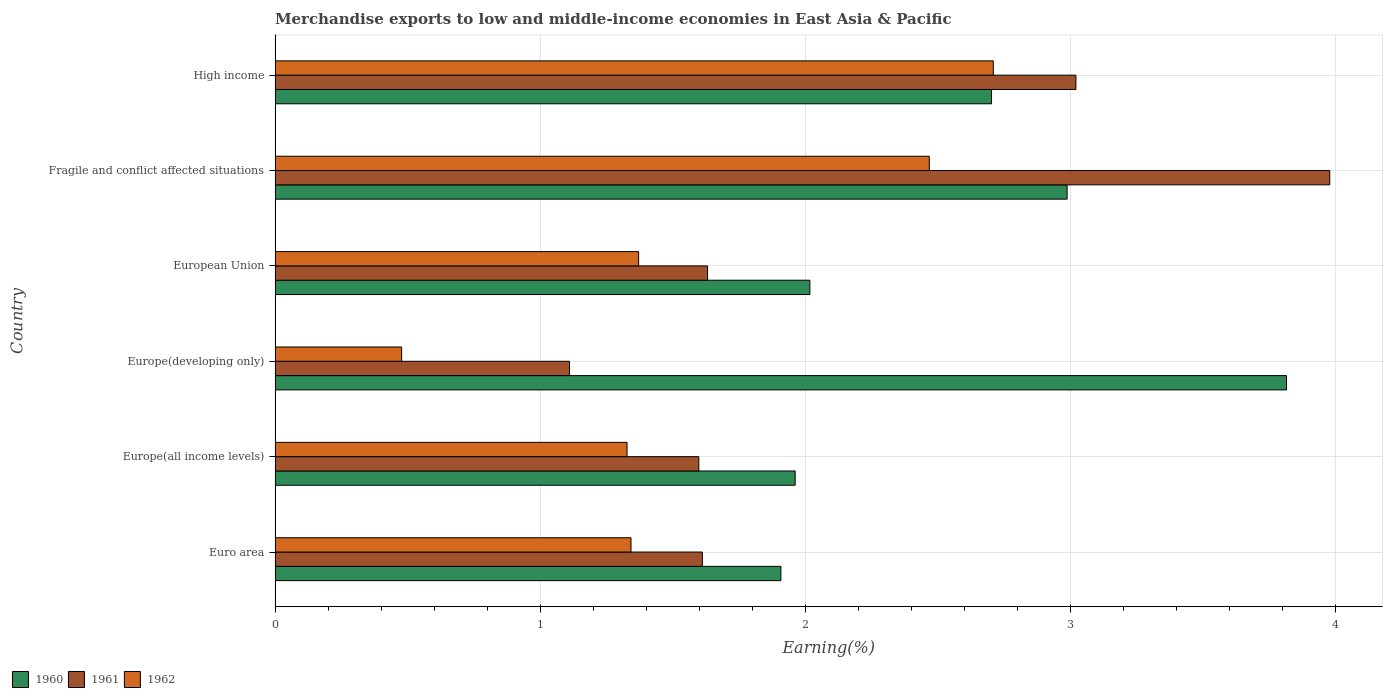How many different coloured bars are there?
Offer a very short reply. 3. How many groups of bars are there?
Keep it short and to the point. 6. Are the number of bars per tick equal to the number of legend labels?
Your answer should be compact. Yes. How many bars are there on the 2nd tick from the bottom?
Offer a terse response. 3. What is the label of the 5th group of bars from the top?
Your answer should be compact. Europe(all income levels). What is the percentage of amount earned from merchandise exports in 1961 in Euro area?
Give a very brief answer. 1.61. Across all countries, what is the maximum percentage of amount earned from merchandise exports in 1961?
Keep it short and to the point. 3.98. Across all countries, what is the minimum percentage of amount earned from merchandise exports in 1960?
Offer a terse response. 1.91. In which country was the percentage of amount earned from merchandise exports in 1961 maximum?
Provide a succinct answer. Fragile and conflict affected situations. What is the total percentage of amount earned from merchandise exports in 1960 in the graph?
Provide a succinct answer. 15.39. What is the difference between the percentage of amount earned from merchandise exports in 1962 in European Union and that in Fragile and conflict affected situations?
Offer a very short reply. -1.1. What is the difference between the percentage of amount earned from merchandise exports in 1961 in Europe(developing only) and the percentage of amount earned from merchandise exports in 1960 in European Union?
Your answer should be compact. -0.91. What is the average percentage of amount earned from merchandise exports in 1961 per country?
Keep it short and to the point. 2.16. What is the difference between the percentage of amount earned from merchandise exports in 1960 and percentage of amount earned from merchandise exports in 1961 in European Union?
Give a very brief answer. 0.39. In how many countries, is the percentage of amount earned from merchandise exports in 1960 greater than 0.6000000000000001 %?
Give a very brief answer. 6. What is the ratio of the percentage of amount earned from merchandise exports in 1960 in Euro area to that in High income?
Your response must be concise. 0.71. What is the difference between the highest and the second highest percentage of amount earned from merchandise exports in 1961?
Make the answer very short. 0.96. What is the difference between the highest and the lowest percentage of amount earned from merchandise exports in 1961?
Provide a short and direct response. 2.87. In how many countries, is the percentage of amount earned from merchandise exports in 1960 greater than the average percentage of amount earned from merchandise exports in 1960 taken over all countries?
Your answer should be compact. 3. Is the sum of the percentage of amount earned from merchandise exports in 1960 in Euro area and Europe(all income levels) greater than the maximum percentage of amount earned from merchandise exports in 1961 across all countries?
Give a very brief answer. No. Are all the bars in the graph horizontal?
Offer a very short reply. Yes. How many countries are there in the graph?
Your answer should be compact. 6. What is the difference between two consecutive major ticks on the X-axis?
Make the answer very short. 1. Does the graph contain grids?
Ensure brevity in your answer.  Yes. Where does the legend appear in the graph?
Offer a terse response. Bottom left. How are the legend labels stacked?
Give a very brief answer. Horizontal. What is the title of the graph?
Provide a succinct answer. Merchandise exports to low and middle-income economies in East Asia & Pacific. What is the label or title of the X-axis?
Provide a succinct answer. Earning(%). What is the Earning(%) of 1960 in Euro area?
Keep it short and to the point. 1.91. What is the Earning(%) of 1961 in Euro area?
Ensure brevity in your answer.  1.61. What is the Earning(%) of 1962 in Euro area?
Your response must be concise. 1.34. What is the Earning(%) in 1960 in Europe(all income levels)?
Ensure brevity in your answer.  1.96. What is the Earning(%) of 1961 in Europe(all income levels)?
Offer a terse response. 1.6. What is the Earning(%) of 1962 in Europe(all income levels)?
Provide a succinct answer. 1.33. What is the Earning(%) in 1960 in Europe(developing only)?
Your answer should be compact. 3.82. What is the Earning(%) in 1961 in Europe(developing only)?
Your answer should be compact. 1.11. What is the Earning(%) in 1962 in Europe(developing only)?
Make the answer very short. 0.48. What is the Earning(%) in 1960 in European Union?
Offer a very short reply. 2.02. What is the Earning(%) in 1961 in European Union?
Offer a terse response. 1.63. What is the Earning(%) in 1962 in European Union?
Your response must be concise. 1.37. What is the Earning(%) of 1960 in Fragile and conflict affected situations?
Make the answer very short. 2.99. What is the Earning(%) in 1961 in Fragile and conflict affected situations?
Ensure brevity in your answer.  3.98. What is the Earning(%) of 1962 in Fragile and conflict affected situations?
Keep it short and to the point. 2.47. What is the Earning(%) in 1960 in High income?
Make the answer very short. 2.7. What is the Earning(%) of 1961 in High income?
Your response must be concise. 3.02. What is the Earning(%) of 1962 in High income?
Offer a very short reply. 2.71. Across all countries, what is the maximum Earning(%) of 1960?
Your answer should be very brief. 3.82. Across all countries, what is the maximum Earning(%) in 1961?
Provide a short and direct response. 3.98. Across all countries, what is the maximum Earning(%) in 1962?
Give a very brief answer. 2.71. Across all countries, what is the minimum Earning(%) of 1960?
Offer a terse response. 1.91. Across all countries, what is the minimum Earning(%) of 1961?
Give a very brief answer. 1.11. Across all countries, what is the minimum Earning(%) of 1962?
Your answer should be very brief. 0.48. What is the total Earning(%) in 1960 in the graph?
Keep it short and to the point. 15.39. What is the total Earning(%) in 1961 in the graph?
Give a very brief answer. 12.95. What is the total Earning(%) of 1962 in the graph?
Your answer should be very brief. 9.7. What is the difference between the Earning(%) in 1960 in Euro area and that in Europe(all income levels)?
Make the answer very short. -0.05. What is the difference between the Earning(%) of 1961 in Euro area and that in Europe(all income levels)?
Your answer should be very brief. 0.01. What is the difference between the Earning(%) of 1962 in Euro area and that in Europe(all income levels)?
Make the answer very short. 0.01. What is the difference between the Earning(%) in 1960 in Euro area and that in Europe(developing only)?
Make the answer very short. -1.91. What is the difference between the Earning(%) in 1961 in Euro area and that in Europe(developing only)?
Your response must be concise. 0.5. What is the difference between the Earning(%) of 1962 in Euro area and that in Europe(developing only)?
Provide a succinct answer. 0.87. What is the difference between the Earning(%) in 1960 in Euro area and that in European Union?
Provide a short and direct response. -0.11. What is the difference between the Earning(%) of 1961 in Euro area and that in European Union?
Offer a very short reply. -0.02. What is the difference between the Earning(%) of 1962 in Euro area and that in European Union?
Provide a short and direct response. -0.03. What is the difference between the Earning(%) of 1960 in Euro area and that in Fragile and conflict affected situations?
Your response must be concise. -1.08. What is the difference between the Earning(%) in 1961 in Euro area and that in Fragile and conflict affected situations?
Make the answer very short. -2.37. What is the difference between the Earning(%) in 1962 in Euro area and that in Fragile and conflict affected situations?
Keep it short and to the point. -1.13. What is the difference between the Earning(%) of 1960 in Euro area and that in High income?
Provide a short and direct response. -0.79. What is the difference between the Earning(%) in 1961 in Euro area and that in High income?
Your answer should be very brief. -1.41. What is the difference between the Earning(%) in 1962 in Euro area and that in High income?
Offer a terse response. -1.37. What is the difference between the Earning(%) in 1960 in Europe(all income levels) and that in Europe(developing only)?
Your response must be concise. -1.85. What is the difference between the Earning(%) in 1961 in Europe(all income levels) and that in Europe(developing only)?
Give a very brief answer. 0.49. What is the difference between the Earning(%) of 1962 in Europe(all income levels) and that in Europe(developing only)?
Provide a succinct answer. 0.85. What is the difference between the Earning(%) of 1960 in Europe(all income levels) and that in European Union?
Offer a very short reply. -0.06. What is the difference between the Earning(%) of 1961 in Europe(all income levels) and that in European Union?
Make the answer very short. -0.03. What is the difference between the Earning(%) of 1962 in Europe(all income levels) and that in European Union?
Your answer should be compact. -0.04. What is the difference between the Earning(%) of 1960 in Europe(all income levels) and that in Fragile and conflict affected situations?
Make the answer very short. -1.03. What is the difference between the Earning(%) of 1961 in Europe(all income levels) and that in Fragile and conflict affected situations?
Ensure brevity in your answer.  -2.38. What is the difference between the Earning(%) in 1962 in Europe(all income levels) and that in Fragile and conflict affected situations?
Your answer should be compact. -1.14. What is the difference between the Earning(%) in 1960 in Europe(all income levels) and that in High income?
Give a very brief answer. -0.74. What is the difference between the Earning(%) in 1961 in Europe(all income levels) and that in High income?
Keep it short and to the point. -1.42. What is the difference between the Earning(%) in 1962 in Europe(all income levels) and that in High income?
Offer a terse response. -1.38. What is the difference between the Earning(%) of 1960 in Europe(developing only) and that in European Union?
Keep it short and to the point. 1.8. What is the difference between the Earning(%) in 1961 in Europe(developing only) and that in European Union?
Keep it short and to the point. -0.52. What is the difference between the Earning(%) of 1962 in Europe(developing only) and that in European Union?
Give a very brief answer. -0.89. What is the difference between the Earning(%) of 1960 in Europe(developing only) and that in Fragile and conflict affected situations?
Give a very brief answer. 0.83. What is the difference between the Earning(%) in 1961 in Europe(developing only) and that in Fragile and conflict affected situations?
Your answer should be very brief. -2.87. What is the difference between the Earning(%) in 1962 in Europe(developing only) and that in Fragile and conflict affected situations?
Keep it short and to the point. -1.99. What is the difference between the Earning(%) in 1960 in Europe(developing only) and that in High income?
Provide a short and direct response. 1.11. What is the difference between the Earning(%) in 1961 in Europe(developing only) and that in High income?
Give a very brief answer. -1.91. What is the difference between the Earning(%) of 1962 in Europe(developing only) and that in High income?
Provide a short and direct response. -2.23. What is the difference between the Earning(%) of 1960 in European Union and that in Fragile and conflict affected situations?
Ensure brevity in your answer.  -0.97. What is the difference between the Earning(%) of 1961 in European Union and that in Fragile and conflict affected situations?
Your response must be concise. -2.35. What is the difference between the Earning(%) of 1962 in European Union and that in Fragile and conflict affected situations?
Provide a succinct answer. -1.1. What is the difference between the Earning(%) of 1960 in European Union and that in High income?
Ensure brevity in your answer.  -0.69. What is the difference between the Earning(%) of 1961 in European Union and that in High income?
Make the answer very short. -1.39. What is the difference between the Earning(%) of 1962 in European Union and that in High income?
Make the answer very short. -1.34. What is the difference between the Earning(%) of 1960 in Fragile and conflict affected situations and that in High income?
Offer a very short reply. 0.29. What is the difference between the Earning(%) of 1961 in Fragile and conflict affected situations and that in High income?
Your response must be concise. 0.96. What is the difference between the Earning(%) of 1962 in Fragile and conflict affected situations and that in High income?
Offer a very short reply. -0.24. What is the difference between the Earning(%) in 1960 in Euro area and the Earning(%) in 1961 in Europe(all income levels)?
Your answer should be compact. 0.31. What is the difference between the Earning(%) in 1960 in Euro area and the Earning(%) in 1962 in Europe(all income levels)?
Offer a terse response. 0.58. What is the difference between the Earning(%) of 1961 in Euro area and the Earning(%) of 1962 in Europe(all income levels)?
Keep it short and to the point. 0.28. What is the difference between the Earning(%) of 1960 in Euro area and the Earning(%) of 1961 in Europe(developing only)?
Provide a succinct answer. 0.8. What is the difference between the Earning(%) of 1960 in Euro area and the Earning(%) of 1962 in Europe(developing only)?
Provide a succinct answer. 1.43. What is the difference between the Earning(%) in 1961 in Euro area and the Earning(%) in 1962 in Europe(developing only)?
Your answer should be very brief. 1.13. What is the difference between the Earning(%) in 1960 in Euro area and the Earning(%) in 1961 in European Union?
Your answer should be compact. 0.28. What is the difference between the Earning(%) in 1960 in Euro area and the Earning(%) in 1962 in European Union?
Keep it short and to the point. 0.54. What is the difference between the Earning(%) of 1961 in Euro area and the Earning(%) of 1962 in European Union?
Your answer should be very brief. 0.24. What is the difference between the Earning(%) in 1960 in Euro area and the Earning(%) in 1961 in Fragile and conflict affected situations?
Provide a succinct answer. -2.07. What is the difference between the Earning(%) of 1960 in Euro area and the Earning(%) of 1962 in Fragile and conflict affected situations?
Your answer should be very brief. -0.56. What is the difference between the Earning(%) of 1961 in Euro area and the Earning(%) of 1962 in Fragile and conflict affected situations?
Provide a short and direct response. -0.86. What is the difference between the Earning(%) in 1960 in Euro area and the Earning(%) in 1961 in High income?
Offer a very short reply. -1.11. What is the difference between the Earning(%) of 1960 in Euro area and the Earning(%) of 1962 in High income?
Ensure brevity in your answer.  -0.8. What is the difference between the Earning(%) in 1961 in Euro area and the Earning(%) in 1962 in High income?
Ensure brevity in your answer.  -1.1. What is the difference between the Earning(%) in 1960 in Europe(all income levels) and the Earning(%) in 1961 in Europe(developing only)?
Your answer should be very brief. 0.85. What is the difference between the Earning(%) in 1960 in Europe(all income levels) and the Earning(%) in 1962 in Europe(developing only)?
Provide a short and direct response. 1.48. What is the difference between the Earning(%) of 1961 in Europe(all income levels) and the Earning(%) of 1962 in Europe(developing only)?
Keep it short and to the point. 1.12. What is the difference between the Earning(%) in 1960 in Europe(all income levels) and the Earning(%) in 1961 in European Union?
Your answer should be very brief. 0.33. What is the difference between the Earning(%) of 1960 in Europe(all income levels) and the Earning(%) of 1962 in European Union?
Give a very brief answer. 0.59. What is the difference between the Earning(%) of 1961 in Europe(all income levels) and the Earning(%) of 1962 in European Union?
Make the answer very short. 0.23. What is the difference between the Earning(%) of 1960 in Europe(all income levels) and the Earning(%) of 1961 in Fragile and conflict affected situations?
Ensure brevity in your answer.  -2.02. What is the difference between the Earning(%) of 1960 in Europe(all income levels) and the Earning(%) of 1962 in Fragile and conflict affected situations?
Provide a succinct answer. -0.51. What is the difference between the Earning(%) in 1961 in Europe(all income levels) and the Earning(%) in 1962 in Fragile and conflict affected situations?
Keep it short and to the point. -0.87. What is the difference between the Earning(%) of 1960 in Europe(all income levels) and the Earning(%) of 1961 in High income?
Ensure brevity in your answer.  -1.06. What is the difference between the Earning(%) in 1960 in Europe(all income levels) and the Earning(%) in 1962 in High income?
Your response must be concise. -0.75. What is the difference between the Earning(%) of 1961 in Europe(all income levels) and the Earning(%) of 1962 in High income?
Make the answer very short. -1.11. What is the difference between the Earning(%) in 1960 in Europe(developing only) and the Earning(%) in 1961 in European Union?
Your answer should be very brief. 2.18. What is the difference between the Earning(%) of 1960 in Europe(developing only) and the Earning(%) of 1962 in European Union?
Give a very brief answer. 2.44. What is the difference between the Earning(%) of 1961 in Europe(developing only) and the Earning(%) of 1962 in European Union?
Provide a succinct answer. -0.26. What is the difference between the Earning(%) of 1960 in Europe(developing only) and the Earning(%) of 1961 in Fragile and conflict affected situations?
Make the answer very short. -0.16. What is the difference between the Earning(%) in 1960 in Europe(developing only) and the Earning(%) in 1962 in Fragile and conflict affected situations?
Provide a short and direct response. 1.35. What is the difference between the Earning(%) of 1961 in Europe(developing only) and the Earning(%) of 1962 in Fragile and conflict affected situations?
Your answer should be compact. -1.36. What is the difference between the Earning(%) in 1960 in Europe(developing only) and the Earning(%) in 1961 in High income?
Provide a short and direct response. 0.79. What is the difference between the Earning(%) in 1960 in Europe(developing only) and the Earning(%) in 1962 in High income?
Offer a terse response. 1.11. What is the difference between the Earning(%) of 1961 in Europe(developing only) and the Earning(%) of 1962 in High income?
Your answer should be compact. -1.6. What is the difference between the Earning(%) in 1960 in European Union and the Earning(%) in 1961 in Fragile and conflict affected situations?
Provide a short and direct response. -1.96. What is the difference between the Earning(%) of 1960 in European Union and the Earning(%) of 1962 in Fragile and conflict affected situations?
Your answer should be compact. -0.45. What is the difference between the Earning(%) of 1961 in European Union and the Earning(%) of 1962 in Fragile and conflict affected situations?
Provide a short and direct response. -0.84. What is the difference between the Earning(%) of 1960 in European Union and the Earning(%) of 1961 in High income?
Give a very brief answer. -1. What is the difference between the Earning(%) in 1960 in European Union and the Earning(%) in 1962 in High income?
Your answer should be very brief. -0.69. What is the difference between the Earning(%) in 1961 in European Union and the Earning(%) in 1962 in High income?
Offer a very short reply. -1.08. What is the difference between the Earning(%) of 1960 in Fragile and conflict affected situations and the Earning(%) of 1961 in High income?
Keep it short and to the point. -0.03. What is the difference between the Earning(%) in 1960 in Fragile and conflict affected situations and the Earning(%) in 1962 in High income?
Your answer should be very brief. 0.28. What is the difference between the Earning(%) in 1961 in Fragile and conflict affected situations and the Earning(%) in 1962 in High income?
Provide a succinct answer. 1.27. What is the average Earning(%) in 1960 per country?
Ensure brevity in your answer.  2.57. What is the average Earning(%) in 1961 per country?
Give a very brief answer. 2.16. What is the average Earning(%) of 1962 per country?
Your answer should be compact. 1.62. What is the difference between the Earning(%) in 1960 and Earning(%) in 1961 in Euro area?
Keep it short and to the point. 0.3. What is the difference between the Earning(%) of 1960 and Earning(%) of 1962 in Euro area?
Give a very brief answer. 0.57. What is the difference between the Earning(%) of 1961 and Earning(%) of 1962 in Euro area?
Keep it short and to the point. 0.27. What is the difference between the Earning(%) of 1960 and Earning(%) of 1961 in Europe(all income levels)?
Provide a short and direct response. 0.36. What is the difference between the Earning(%) of 1960 and Earning(%) of 1962 in Europe(all income levels)?
Provide a short and direct response. 0.63. What is the difference between the Earning(%) of 1961 and Earning(%) of 1962 in Europe(all income levels)?
Offer a terse response. 0.27. What is the difference between the Earning(%) in 1960 and Earning(%) in 1961 in Europe(developing only)?
Your answer should be compact. 2.7. What is the difference between the Earning(%) in 1960 and Earning(%) in 1962 in Europe(developing only)?
Offer a very short reply. 3.34. What is the difference between the Earning(%) in 1961 and Earning(%) in 1962 in Europe(developing only)?
Your answer should be very brief. 0.63. What is the difference between the Earning(%) of 1960 and Earning(%) of 1961 in European Union?
Keep it short and to the point. 0.39. What is the difference between the Earning(%) of 1960 and Earning(%) of 1962 in European Union?
Your answer should be compact. 0.65. What is the difference between the Earning(%) in 1961 and Earning(%) in 1962 in European Union?
Your answer should be very brief. 0.26. What is the difference between the Earning(%) in 1960 and Earning(%) in 1961 in Fragile and conflict affected situations?
Keep it short and to the point. -0.99. What is the difference between the Earning(%) in 1960 and Earning(%) in 1962 in Fragile and conflict affected situations?
Your answer should be very brief. 0.52. What is the difference between the Earning(%) of 1961 and Earning(%) of 1962 in Fragile and conflict affected situations?
Offer a terse response. 1.51. What is the difference between the Earning(%) of 1960 and Earning(%) of 1961 in High income?
Give a very brief answer. -0.32. What is the difference between the Earning(%) in 1960 and Earning(%) in 1962 in High income?
Your answer should be very brief. -0.01. What is the difference between the Earning(%) of 1961 and Earning(%) of 1962 in High income?
Give a very brief answer. 0.31. What is the ratio of the Earning(%) of 1960 in Euro area to that in Europe(all income levels)?
Your response must be concise. 0.97. What is the ratio of the Earning(%) of 1961 in Euro area to that in Europe(all income levels)?
Your answer should be compact. 1.01. What is the ratio of the Earning(%) in 1962 in Euro area to that in Europe(all income levels)?
Provide a succinct answer. 1.01. What is the ratio of the Earning(%) of 1960 in Euro area to that in Europe(developing only)?
Keep it short and to the point. 0.5. What is the ratio of the Earning(%) in 1961 in Euro area to that in Europe(developing only)?
Keep it short and to the point. 1.45. What is the ratio of the Earning(%) in 1962 in Euro area to that in Europe(developing only)?
Offer a very short reply. 2.81. What is the ratio of the Earning(%) in 1960 in Euro area to that in European Union?
Your answer should be compact. 0.95. What is the ratio of the Earning(%) of 1961 in Euro area to that in European Union?
Your response must be concise. 0.99. What is the ratio of the Earning(%) of 1962 in Euro area to that in European Union?
Your answer should be very brief. 0.98. What is the ratio of the Earning(%) in 1960 in Euro area to that in Fragile and conflict affected situations?
Offer a terse response. 0.64. What is the ratio of the Earning(%) of 1961 in Euro area to that in Fragile and conflict affected situations?
Offer a terse response. 0.41. What is the ratio of the Earning(%) of 1962 in Euro area to that in Fragile and conflict affected situations?
Offer a very short reply. 0.54. What is the ratio of the Earning(%) in 1960 in Euro area to that in High income?
Provide a succinct answer. 0.71. What is the ratio of the Earning(%) in 1961 in Euro area to that in High income?
Provide a succinct answer. 0.53. What is the ratio of the Earning(%) in 1962 in Euro area to that in High income?
Provide a short and direct response. 0.5. What is the ratio of the Earning(%) of 1960 in Europe(all income levels) to that in Europe(developing only)?
Your response must be concise. 0.51. What is the ratio of the Earning(%) in 1961 in Europe(all income levels) to that in Europe(developing only)?
Ensure brevity in your answer.  1.44. What is the ratio of the Earning(%) in 1962 in Europe(all income levels) to that in Europe(developing only)?
Offer a terse response. 2.78. What is the ratio of the Earning(%) in 1960 in Europe(all income levels) to that in European Union?
Keep it short and to the point. 0.97. What is the ratio of the Earning(%) of 1961 in Europe(all income levels) to that in European Union?
Ensure brevity in your answer.  0.98. What is the ratio of the Earning(%) in 1962 in Europe(all income levels) to that in European Union?
Provide a succinct answer. 0.97. What is the ratio of the Earning(%) in 1960 in Europe(all income levels) to that in Fragile and conflict affected situations?
Your answer should be compact. 0.66. What is the ratio of the Earning(%) of 1961 in Europe(all income levels) to that in Fragile and conflict affected situations?
Keep it short and to the point. 0.4. What is the ratio of the Earning(%) of 1962 in Europe(all income levels) to that in Fragile and conflict affected situations?
Give a very brief answer. 0.54. What is the ratio of the Earning(%) of 1960 in Europe(all income levels) to that in High income?
Ensure brevity in your answer.  0.73. What is the ratio of the Earning(%) in 1961 in Europe(all income levels) to that in High income?
Make the answer very short. 0.53. What is the ratio of the Earning(%) of 1962 in Europe(all income levels) to that in High income?
Your answer should be very brief. 0.49. What is the ratio of the Earning(%) of 1960 in Europe(developing only) to that in European Union?
Offer a terse response. 1.89. What is the ratio of the Earning(%) of 1961 in Europe(developing only) to that in European Union?
Offer a terse response. 0.68. What is the ratio of the Earning(%) of 1962 in Europe(developing only) to that in European Union?
Offer a very short reply. 0.35. What is the ratio of the Earning(%) of 1960 in Europe(developing only) to that in Fragile and conflict affected situations?
Provide a short and direct response. 1.28. What is the ratio of the Earning(%) in 1961 in Europe(developing only) to that in Fragile and conflict affected situations?
Keep it short and to the point. 0.28. What is the ratio of the Earning(%) of 1962 in Europe(developing only) to that in Fragile and conflict affected situations?
Offer a terse response. 0.19. What is the ratio of the Earning(%) in 1960 in Europe(developing only) to that in High income?
Offer a very short reply. 1.41. What is the ratio of the Earning(%) of 1961 in Europe(developing only) to that in High income?
Your answer should be very brief. 0.37. What is the ratio of the Earning(%) of 1962 in Europe(developing only) to that in High income?
Your answer should be compact. 0.18. What is the ratio of the Earning(%) in 1960 in European Union to that in Fragile and conflict affected situations?
Ensure brevity in your answer.  0.68. What is the ratio of the Earning(%) in 1961 in European Union to that in Fragile and conflict affected situations?
Offer a terse response. 0.41. What is the ratio of the Earning(%) in 1962 in European Union to that in Fragile and conflict affected situations?
Your answer should be compact. 0.56. What is the ratio of the Earning(%) of 1960 in European Union to that in High income?
Your answer should be compact. 0.75. What is the ratio of the Earning(%) of 1961 in European Union to that in High income?
Offer a very short reply. 0.54. What is the ratio of the Earning(%) of 1962 in European Union to that in High income?
Provide a short and direct response. 0.51. What is the ratio of the Earning(%) in 1960 in Fragile and conflict affected situations to that in High income?
Provide a short and direct response. 1.11. What is the ratio of the Earning(%) of 1961 in Fragile and conflict affected situations to that in High income?
Provide a short and direct response. 1.32. What is the ratio of the Earning(%) in 1962 in Fragile and conflict affected situations to that in High income?
Offer a very short reply. 0.91. What is the difference between the highest and the second highest Earning(%) in 1960?
Give a very brief answer. 0.83. What is the difference between the highest and the second highest Earning(%) in 1961?
Offer a very short reply. 0.96. What is the difference between the highest and the second highest Earning(%) in 1962?
Offer a terse response. 0.24. What is the difference between the highest and the lowest Earning(%) of 1960?
Provide a succinct answer. 1.91. What is the difference between the highest and the lowest Earning(%) in 1961?
Provide a succinct answer. 2.87. What is the difference between the highest and the lowest Earning(%) of 1962?
Offer a terse response. 2.23. 